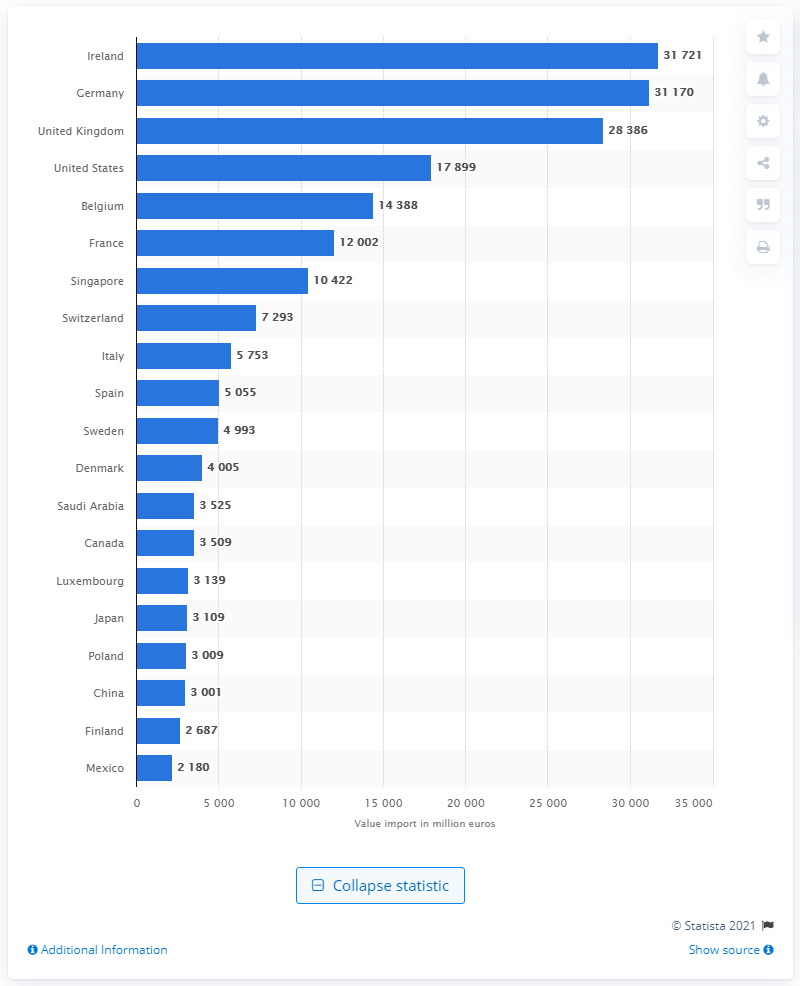What was the value of service exports to the U.S. in the same year?
 17899 